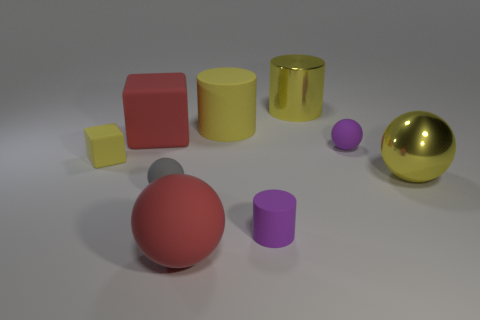Add 1 blue metallic cylinders. How many objects exist? 10 Subtract all cylinders. How many objects are left? 6 Subtract 1 yellow balls. How many objects are left? 8 Subtract all cyan cylinders. Subtract all spheres. How many objects are left? 5 Add 7 purple balls. How many purple balls are left? 8 Add 1 purple matte balls. How many purple matte balls exist? 2 